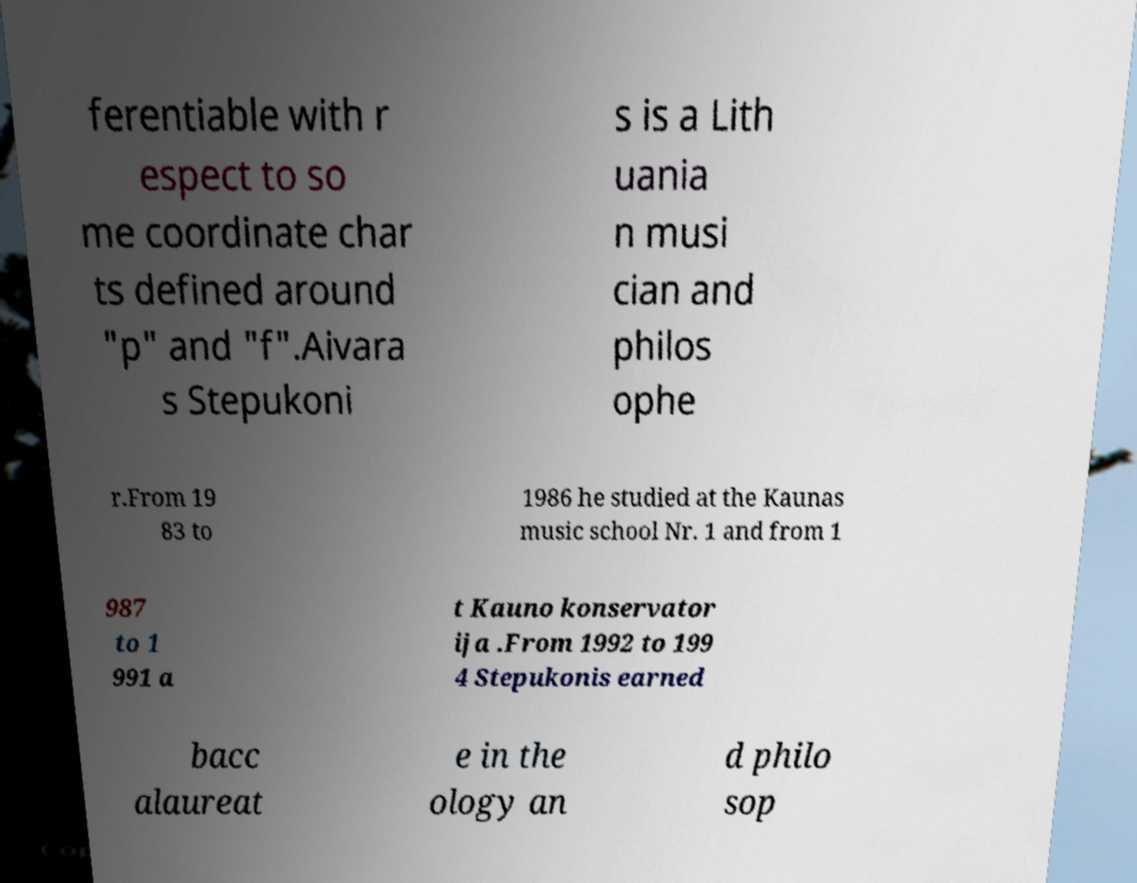Could you assist in decoding the text presented in this image and type it out clearly? ferentiable with r espect to so me coordinate char ts defined around "p" and "f".Aivara s Stepukoni s is a Lith uania n musi cian and philos ophe r.From 19 83 to 1986 he studied at the Kaunas music school Nr. 1 and from 1 987 to 1 991 a t Kauno konservator ija .From 1992 to 199 4 Stepukonis earned bacc alaureat e in the ology an d philo sop 